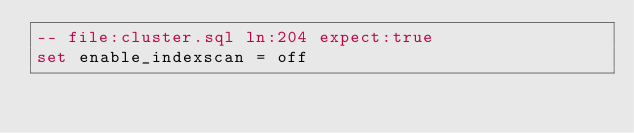Convert code to text. <code><loc_0><loc_0><loc_500><loc_500><_SQL_>-- file:cluster.sql ln:204 expect:true
set enable_indexscan = off
</code> 